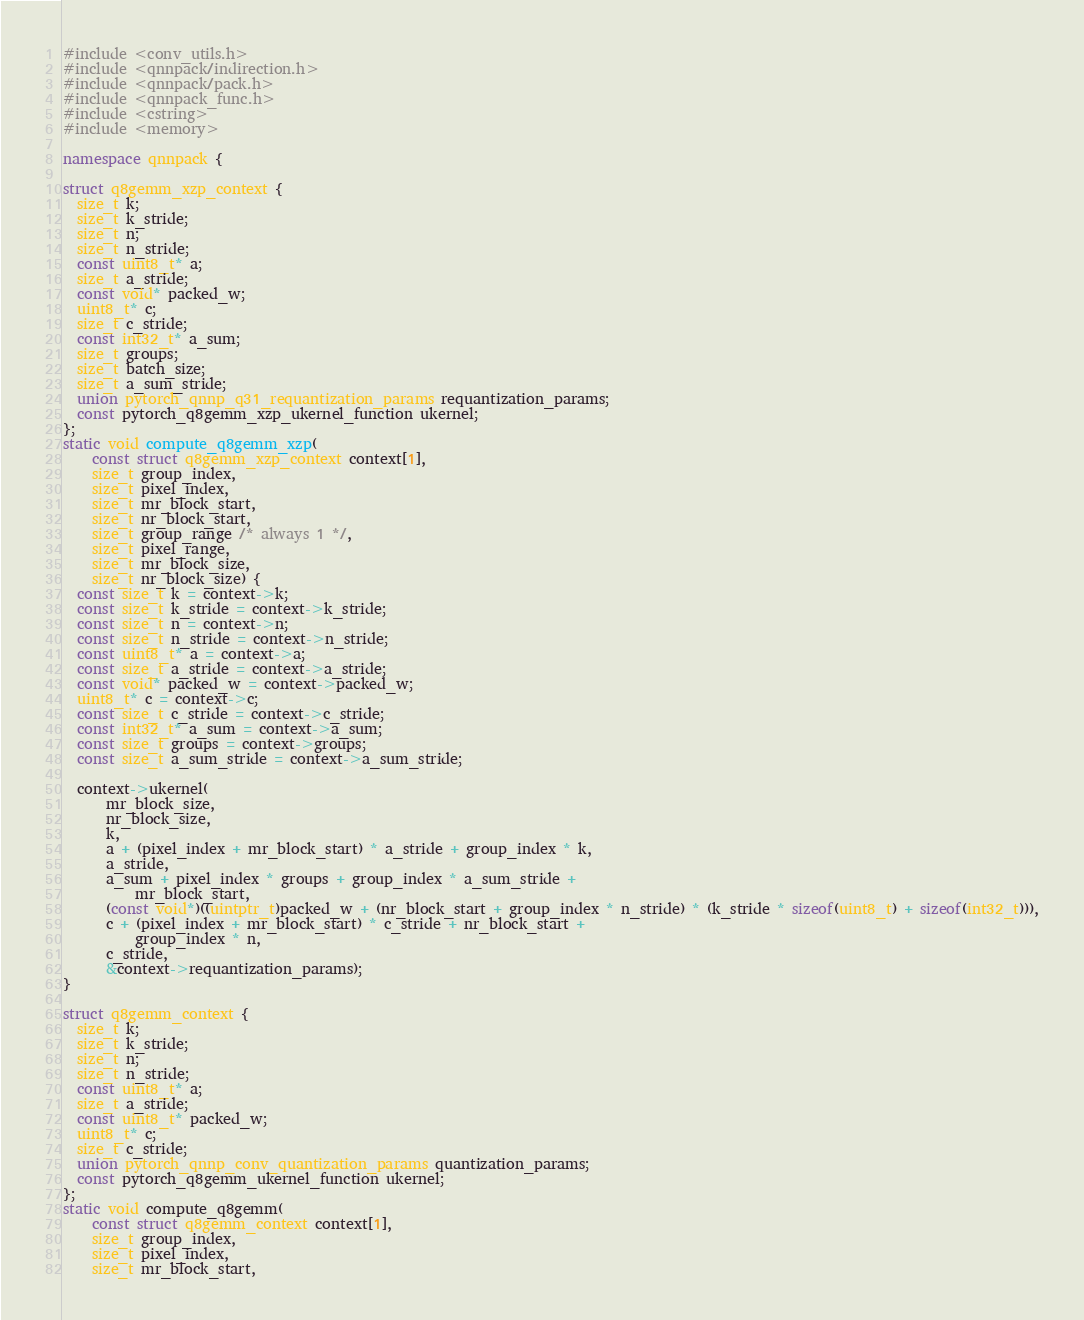<code> <loc_0><loc_0><loc_500><loc_500><_C++_>#include <conv_utils.h>
#include <qnnpack/indirection.h>
#include <qnnpack/pack.h>
#include <qnnpack_func.h>
#include <cstring>
#include <memory>

namespace qnnpack {

struct q8gemm_xzp_context {
  size_t k;
  size_t k_stride;
  size_t n;
  size_t n_stride;
  const uint8_t* a;
  size_t a_stride;
  const void* packed_w;
  uint8_t* c;
  size_t c_stride;
  const int32_t* a_sum;
  size_t groups;
  size_t batch_size;
  size_t a_sum_stride;
  union pytorch_qnnp_q31_requantization_params requantization_params;
  const pytorch_q8gemm_xzp_ukernel_function ukernel;
};
static void compute_q8gemm_xzp(
    const struct q8gemm_xzp_context context[1],
    size_t group_index,
    size_t pixel_index,
    size_t mr_block_start,
    size_t nr_block_start,
    size_t group_range /* always 1 */,
    size_t pixel_range,
    size_t mr_block_size,
    size_t nr_block_size) {
  const size_t k = context->k;
  const size_t k_stride = context->k_stride;
  const size_t n = context->n;
  const size_t n_stride = context->n_stride;
  const uint8_t* a = context->a;
  const size_t a_stride = context->a_stride;
  const void* packed_w = context->packed_w;
  uint8_t* c = context->c;
  const size_t c_stride = context->c_stride;
  const int32_t* a_sum = context->a_sum;
  const size_t groups = context->groups;
  const size_t a_sum_stride = context->a_sum_stride;

  context->ukernel(
      mr_block_size,
      nr_block_size,
      k,
      a + (pixel_index + mr_block_start) * a_stride + group_index * k,
      a_stride,
      a_sum + pixel_index * groups + group_index * a_sum_stride +
          mr_block_start,
      (const void*)((uintptr_t)packed_w + (nr_block_start + group_index * n_stride) * (k_stride * sizeof(uint8_t) + sizeof(int32_t))),
      c + (pixel_index + mr_block_start) * c_stride + nr_block_start +
          group_index * n,
      c_stride,
      &context->requantization_params);
}

struct q8gemm_context {
  size_t k;
  size_t k_stride;
  size_t n;
  size_t n_stride;
  const uint8_t* a;
  size_t a_stride;
  const uint8_t* packed_w;
  uint8_t* c;
  size_t c_stride;
  union pytorch_qnnp_conv_quantization_params quantization_params;
  const pytorch_q8gemm_ukernel_function ukernel;
};
static void compute_q8gemm(
    const struct q8gemm_context context[1],
    size_t group_index,
    size_t pixel_index,
    size_t mr_block_start,</code> 